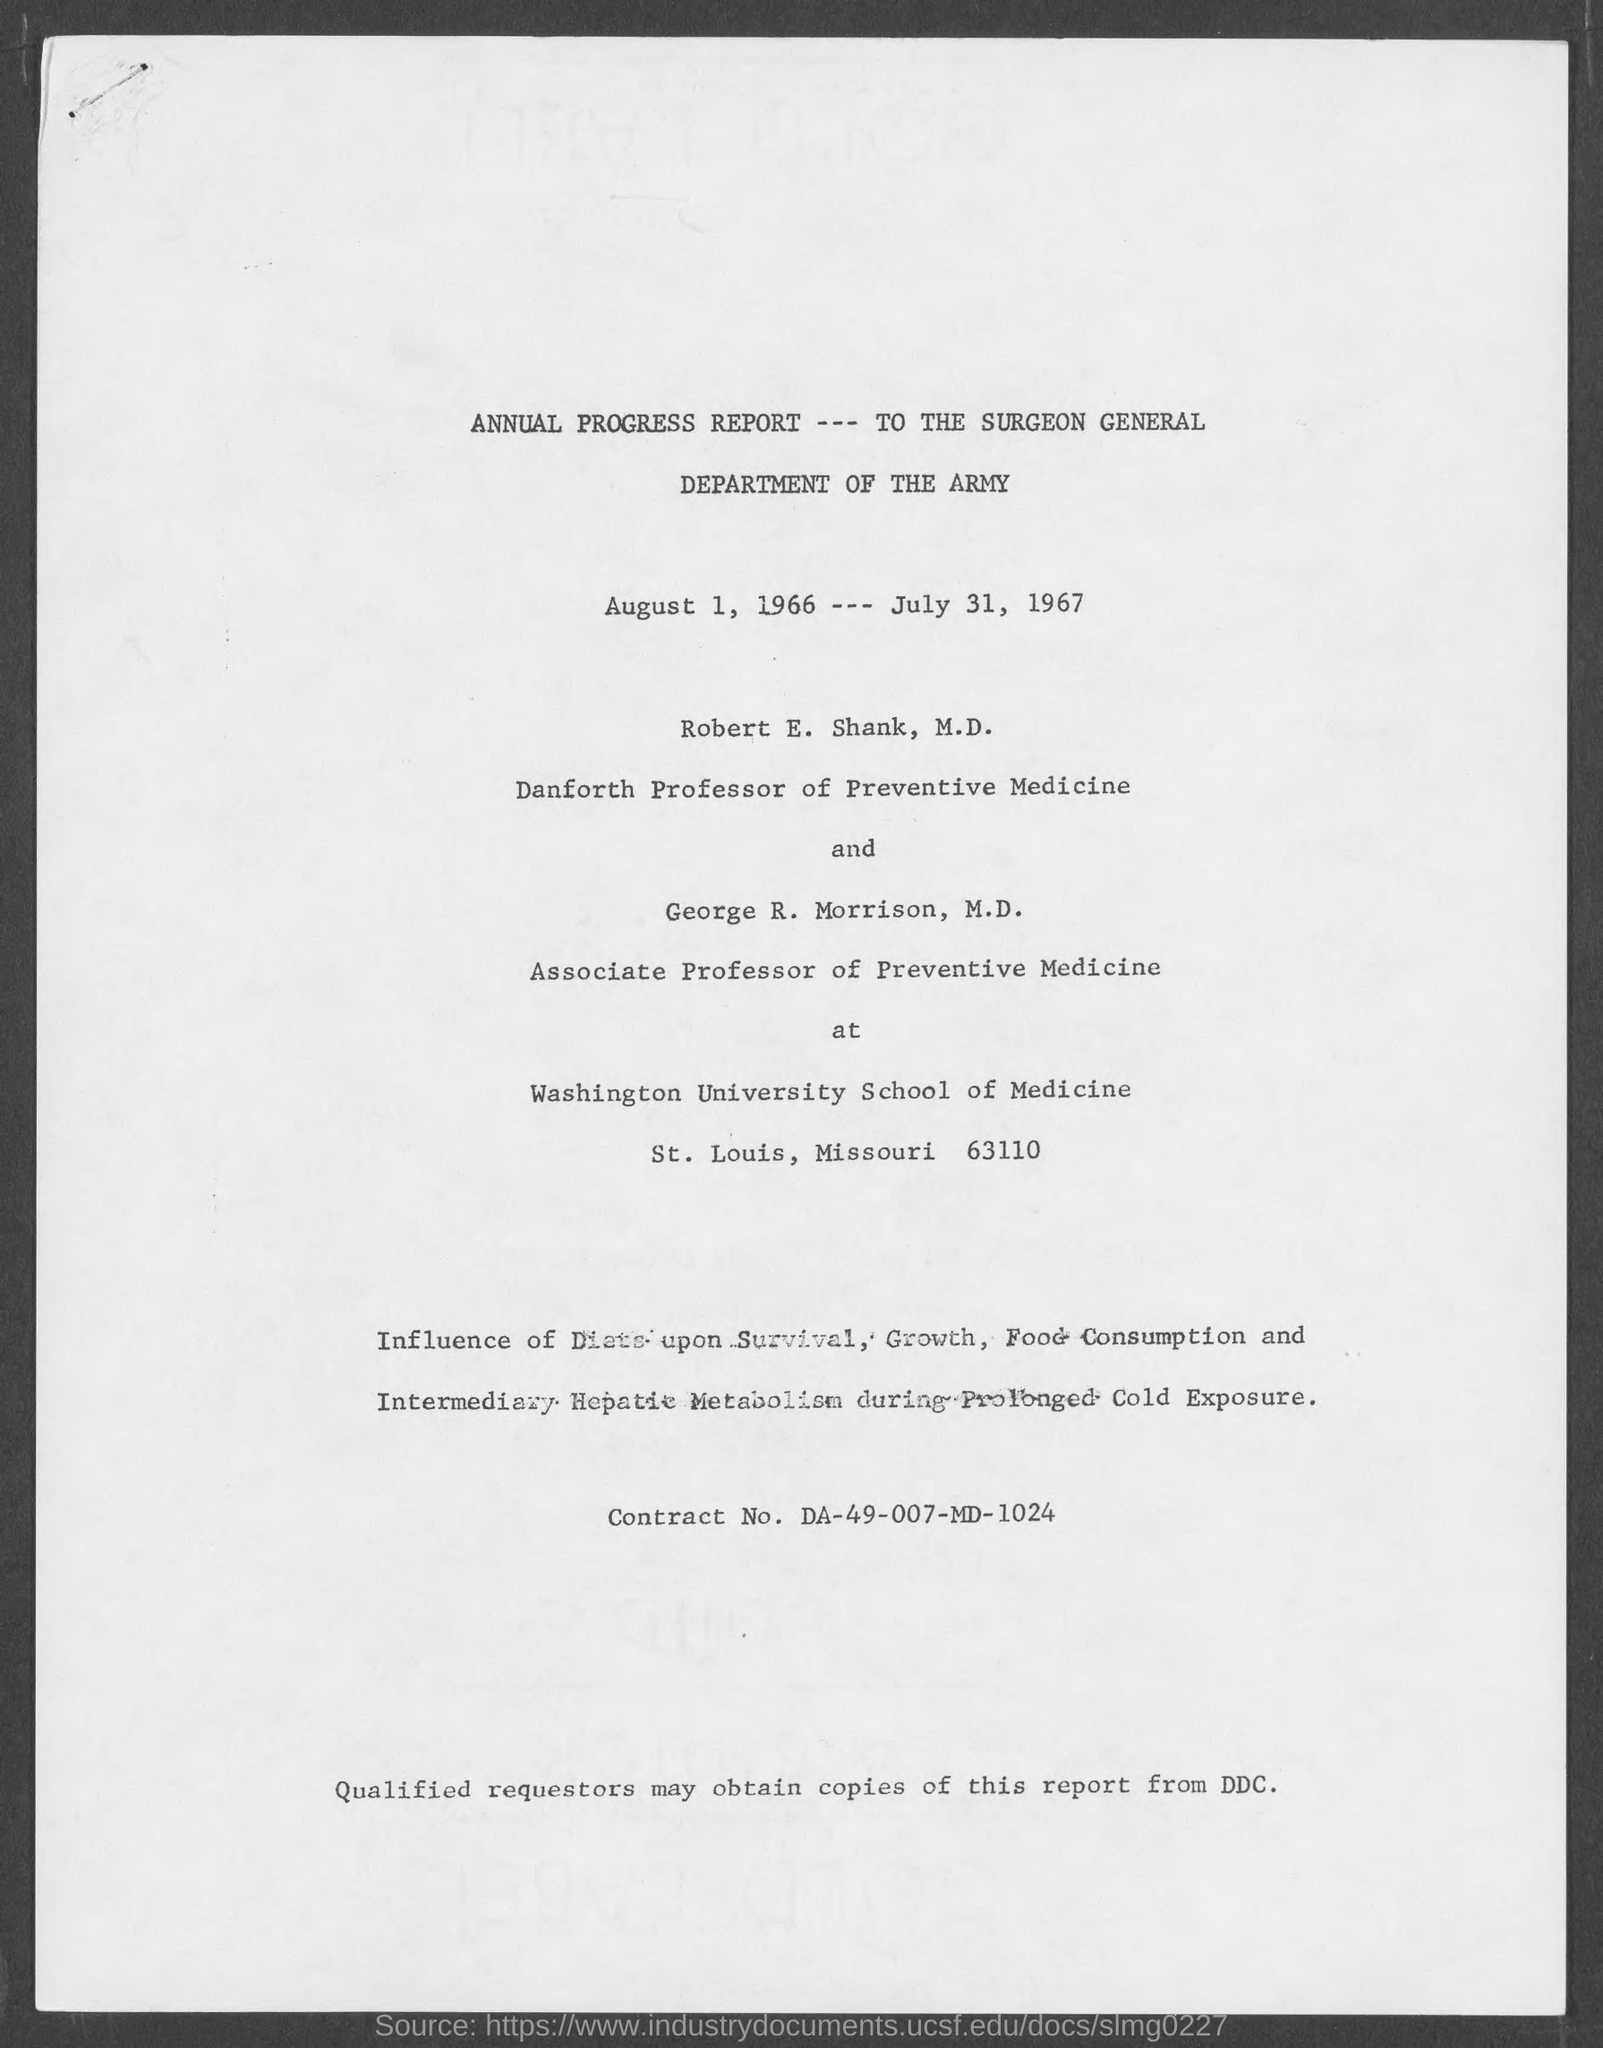Highlight a few significant elements in this photo. The contract number mentioned in the given page is DA-49-007-MD-1024. George R. Morrison is designated as an Associate Professor of Preventive Medicine, as mentioned in the given form. The Department of the Army is the name of the department mentioned in the given form. Annual Progress Report is the name of the report mentioned in the given page. Robert E. Shank is referred to as the Danforth Professor of Preventive Medicine in the given form. 